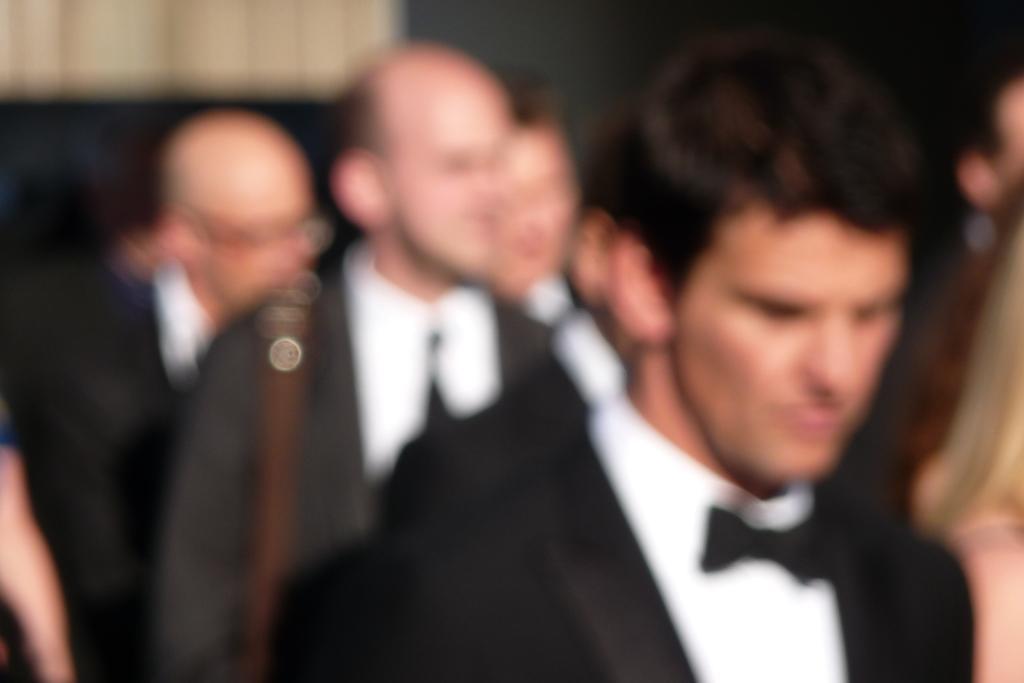Can you describe this image briefly? In this image there are few persons. Right side there is a person wearing a suit and tie. 